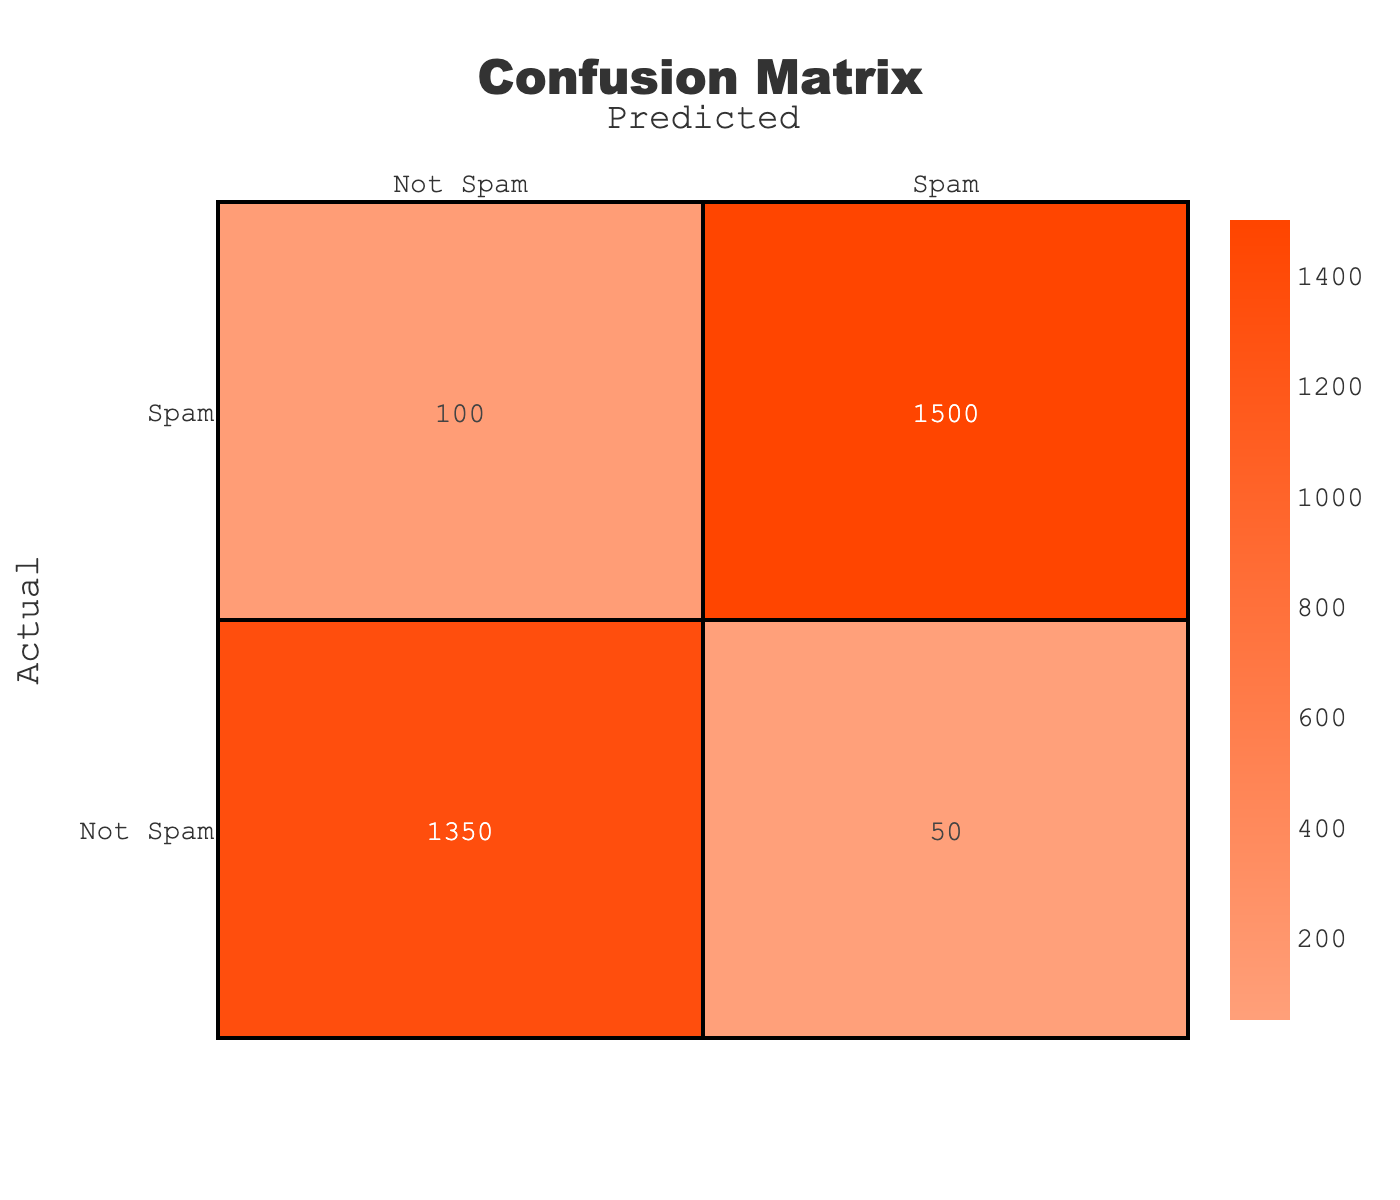What is the count of emails classified as Spam that are actually Spam? The table indicates that the count for emails that are classified as Spam and are actually Spam is listed in the cell corresponding to the row "Spam" and column "Spam". The value in that cell is 1500.
Answer: 1500 What is the total number of emails classified as Not Spam? To determine this, we need to sum the counts for both predicted categories under the Not Spam row. The values are 50 (Not Spam classified as Spam) and 1350 (Not Spam classified as Not Spam). Thus, the total is 50 + 1350 = 1400.
Answer: 1400 Is the number of actual Spam emails greater than the number of actual Not Spam emails? We compare the actual Spam, which is the sum of 1500 and 100 (Spam classified as Spam and Not Spam), against the actual Not Spam, which is the sum of 1350 and 50 (Not Spam classified as Not Spam and Spam). So, total Spam = 1500 + 100 = 1600, and total Not Spam = 1350 + 50 = 1400. Since 1600 is greater than 1400, the answer is yes.
Answer: Yes What percentage of emails classified as Spam were actual Spam? To find the percentage of Spam classified emails that are actually Spam, we take the count of Spam that are actually Spam (1500) and divide it by the total number of emails classified as Spam. The total is 1500 (Spam classified as Spam) + 50 (Not Spam classified as Spam) = 1550. Thus, the percentage is calculated as (1500 / 1550) * 100, which equals approximately 96.77%.
Answer: 96.77% If we consider false positives as the count of Not Spam emails that were incorrectly classified as Spam, what is the count of false positives? The false positives are represented by the count of Not Spam emails that were predicted as Spam, which is 50 (indicated in the row "Not Spam" and column "Spam").
Answer: 50 What is the total number of emails in the dataset? To find the total number of emails, we need to add all the counts across the entire confusion matrix. This includes 1500 (Spam, Spam), 100 (Spam, Not Spam), 50 (Not Spam, Spam), and 1350 (Not Spam, Not Spam): 1500 + 100 + 50 + 1350 = 3000.
Answer: 3000 How many actual Not Spam emails were classified correctly? The correct classification for actual Not Spam emails is given by the count of Not Spam emails predicted as Not Spam, which is located at row "Not Spam" and column "Not Spam". This value is 1350.
Answer: 1350 What is the ratio of true positives to false negatives in this confusion matrix? True positives are found at the intersection of actual Spam and predicted Spam, which gives us 1500. False negatives are found at the intersection of actual Spam and predicted Not Spam, which is 100. Therefore, the ratio is 1500 (true positives) to 100 (false negatives), which simplifies to 15:1.
Answer: 15:1 